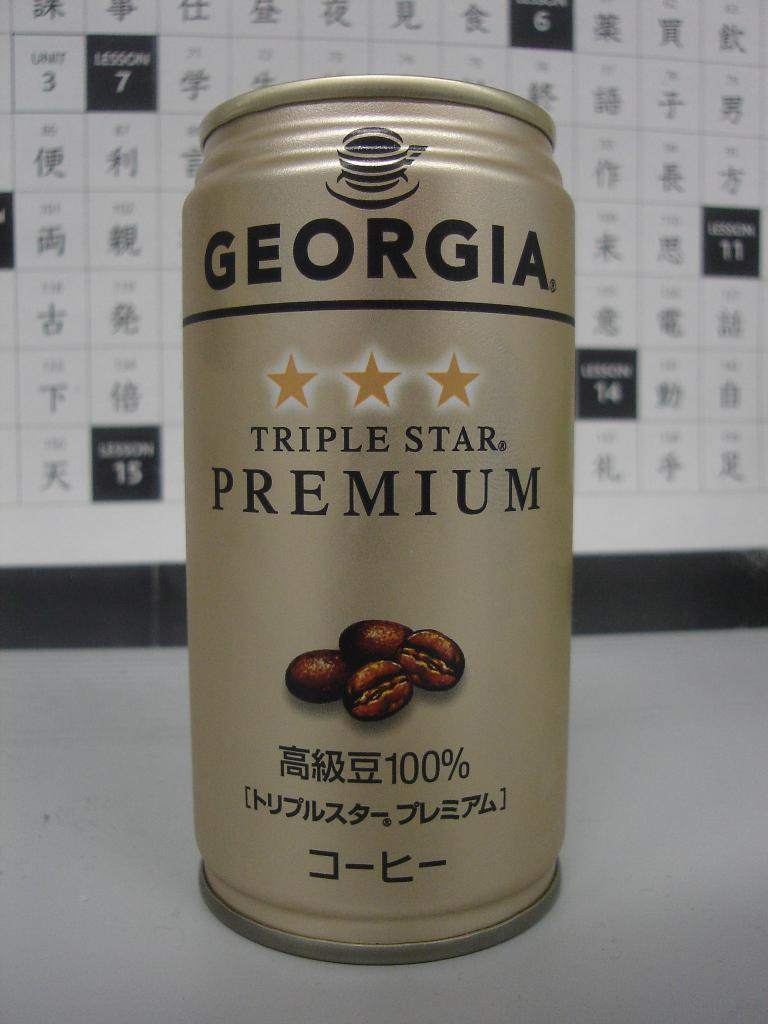Provide a one-sentence caption for the provided image. The coffee drink is called Georgia Triple Star Premium. 